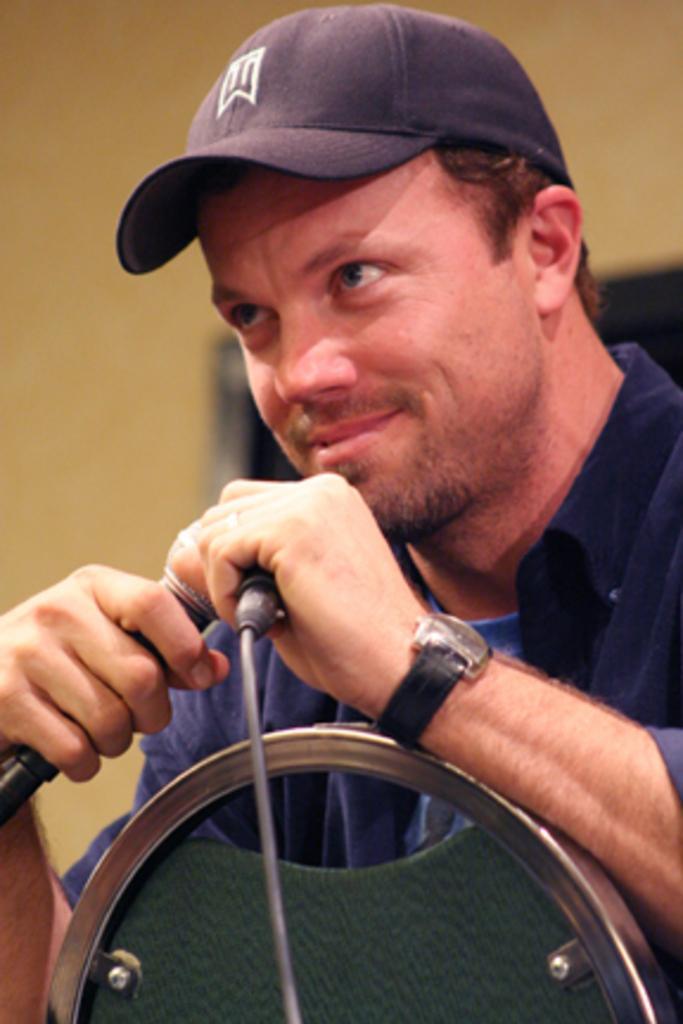Please provide a concise description of this image. In this image a person is sitting wearing a cap , blue shirt. He is holding a mic. He is wearing a watch. In the background there is a yellow wall. 